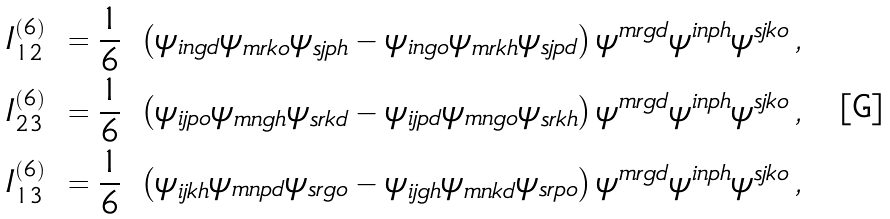<formula> <loc_0><loc_0><loc_500><loc_500>I _ { 1 2 } ^ { ( 6 ) } \ & = \frac { 1 } { 6 } \ \left ( \psi _ { i n g d } \psi _ { m r k o } \psi _ { s j p h } - \psi _ { i n g o } \psi _ { m r k h } \psi _ { s j p d } \right ) \psi ^ { m r g d } \psi ^ { i n p h } \psi ^ { s j k o } \, , \\ I _ { 2 3 } ^ { ( 6 ) } \ & = \frac { 1 } { 6 } \ \left ( \psi _ { i j p o } \psi _ { m n g h } \psi _ { s r k d } - \psi _ { i j p d } \psi _ { m n g o } \psi _ { s r k h } \right ) \psi ^ { m r g d } \psi ^ { i n p h } \psi ^ { s j k o } \, , \\ I _ { 1 3 } ^ { ( 6 ) } \ & = \frac { 1 } { 6 } \ \left ( \psi _ { i j k h } \psi _ { m n p d } \psi _ { s r g o } - \psi _ { i j g h } \psi _ { m n k d } \psi _ { s r p o } \right ) \psi ^ { m r g d } \psi ^ { i n p h } \psi ^ { s j k o } \, ,</formula> 